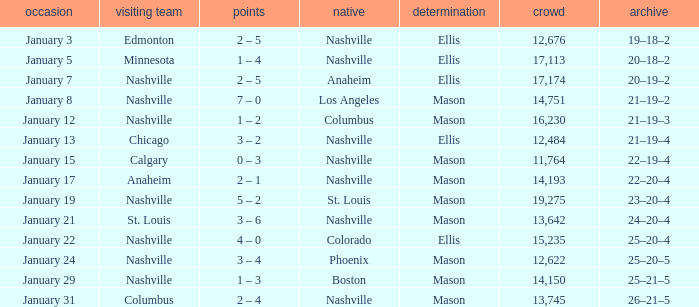On January 15, what was the most in attendance? 11764.0. 